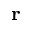Convert formula to latex. <formula><loc_0><loc_0><loc_500><loc_500>r</formula> 